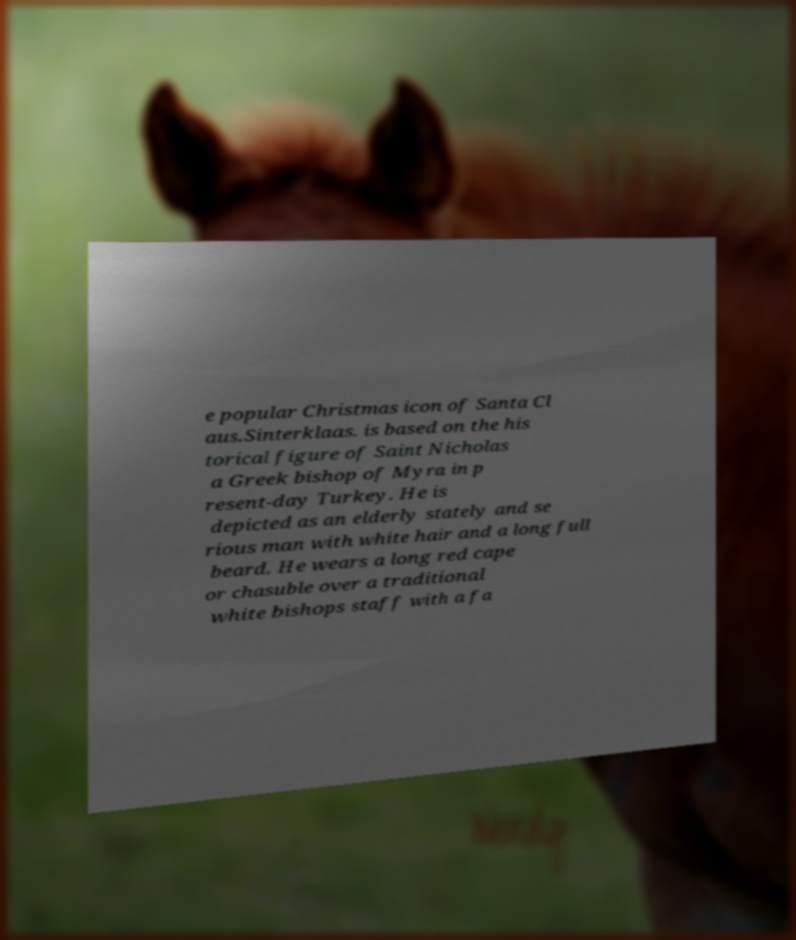There's text embedded in this image that I need extracted. Can you transcribe it verbatim? e popular Christmas icon of Santa Cl aus.Sinterklaas. is based on the his torical figure of Saint Nicholas a Greek bishop of Myra in p resent-day Turkey. He is depicted as an elderly stately and se rious man with white hair and a long full beard. He wears a long red cape or chasuble over a traditional white bishops staff with a fa 